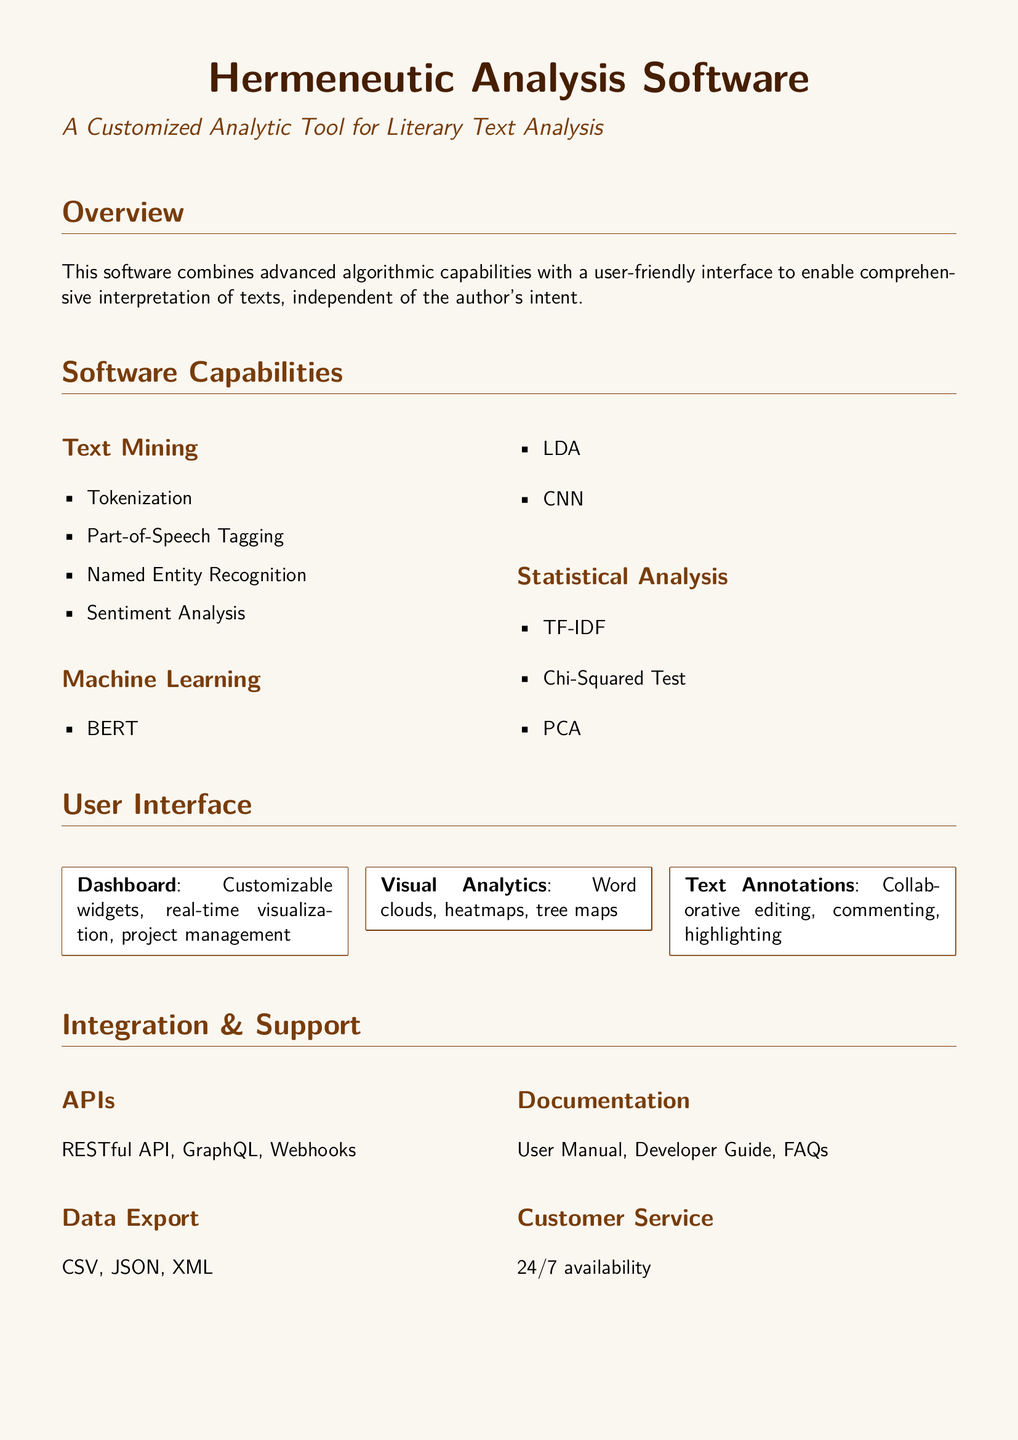What is the name of the software? The document highlights the software as "Hermeneutic Analysis Software."
Answer: Hermeneutic Analysis Software What type of analysis does the software focus on? The overview specifies that the software is for "literary text analysis."
Answer: literary text analysis Which algorithm is used under Machine Learning capabilities? The software includes "BERT" as one of its algorithms under Machine Learning.
Answer: BERT What format is available for Data Export? The document lists "CSV, JSON, XML" as available formats for data export.
Answer: CSV, JSON, XML What feature is described for the Dashboard? The Dashboard feature includes "Customizable widgets, real-time visualization, project management."
Answer: Customizable widgets, real-time visualization, project management Which compliance standards are mentioned? The document notes that the software complies with "GDPR, ISO/IEC 27001."
Answer: GDPR, ISO/IEC 27001 What is the user service availability? The document states the customer service is available "24/7."
Answer: 24/7 What is the purpose of the software according to the document? The final note in the document emphasizes that it is about "empowering the reader's interpretation."
Answer: empowering the reader's interpretation 